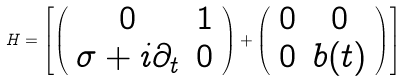Convert formula to latex. <formula><loc_0><loc_0><loc_500><loc_500>H = \left [ \left ( \begin{array} { c c } 0 & 1 \\ \sigma + i \partial _ { t } & 0 \end{array} \right ) + \left ( \begin{array} { c c } 0 & 0 \\ 0 & b ( t ) \end{array} \right ) \right ]</formula> 